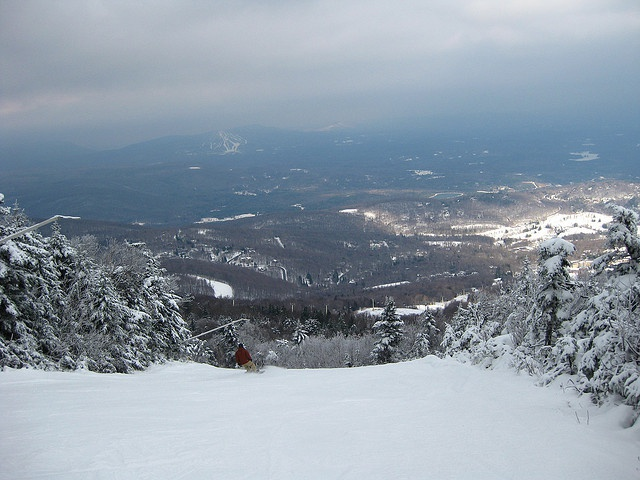Describe the objects in this image and their specific colors. I can see people in darkgray, black, maroon, and gray tones in this image. 